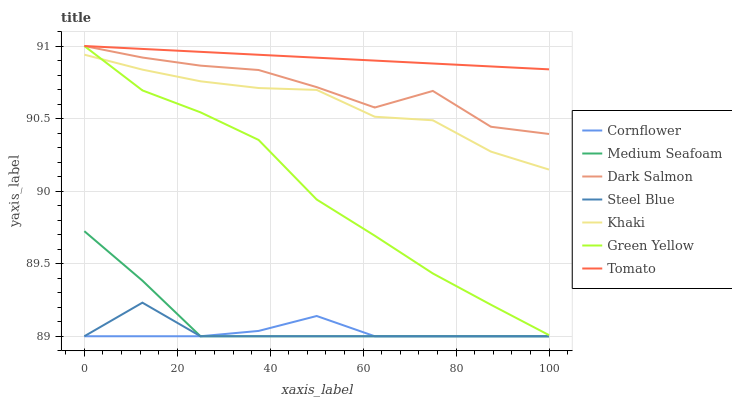Does Cornflower have the minimum area under the curve?
Answer yes or no. Yes. Does Tomato have the maximum area under the curve?
Answer yes or no. Yes. Does Khaki have the minimum area under the curve?
Answer yes or no. No. Does Khaki have the maximum area under the curve?
Answer yes or no. No. Is Tomato the smoothest?
Answer yes or no. Yes. Is Dark Salmon the roughest?
Answer yes or no. Yes. Is Cornflower the smoothest?
Answer yes or no. No. Is Cornflower the roughest?
Answer yes or no. No. Does Khaki have the lowest value?
Answer yes or no. No. Does Green Yellow have the highest value?
Answer yes or no. Yes. Does Khaki have the highest value?
Answer yes or no. No. Is Medium Seafoam less than Dark Salmon?
Answer yes or no. Yes. Is Khaki greater than Steel Blue?
Answer yes or no. Yes. Does Green Yellow intersect Khaki?
Answer yes or no. Yes. Is Green Yellow less than Khaki?
Answer yes or no. No. Is Green Yellow greater than Khaki?
Answer yes or no. No. Does Medium Seafoam intersect Dark Salmon?
Answer yes or no. No. 